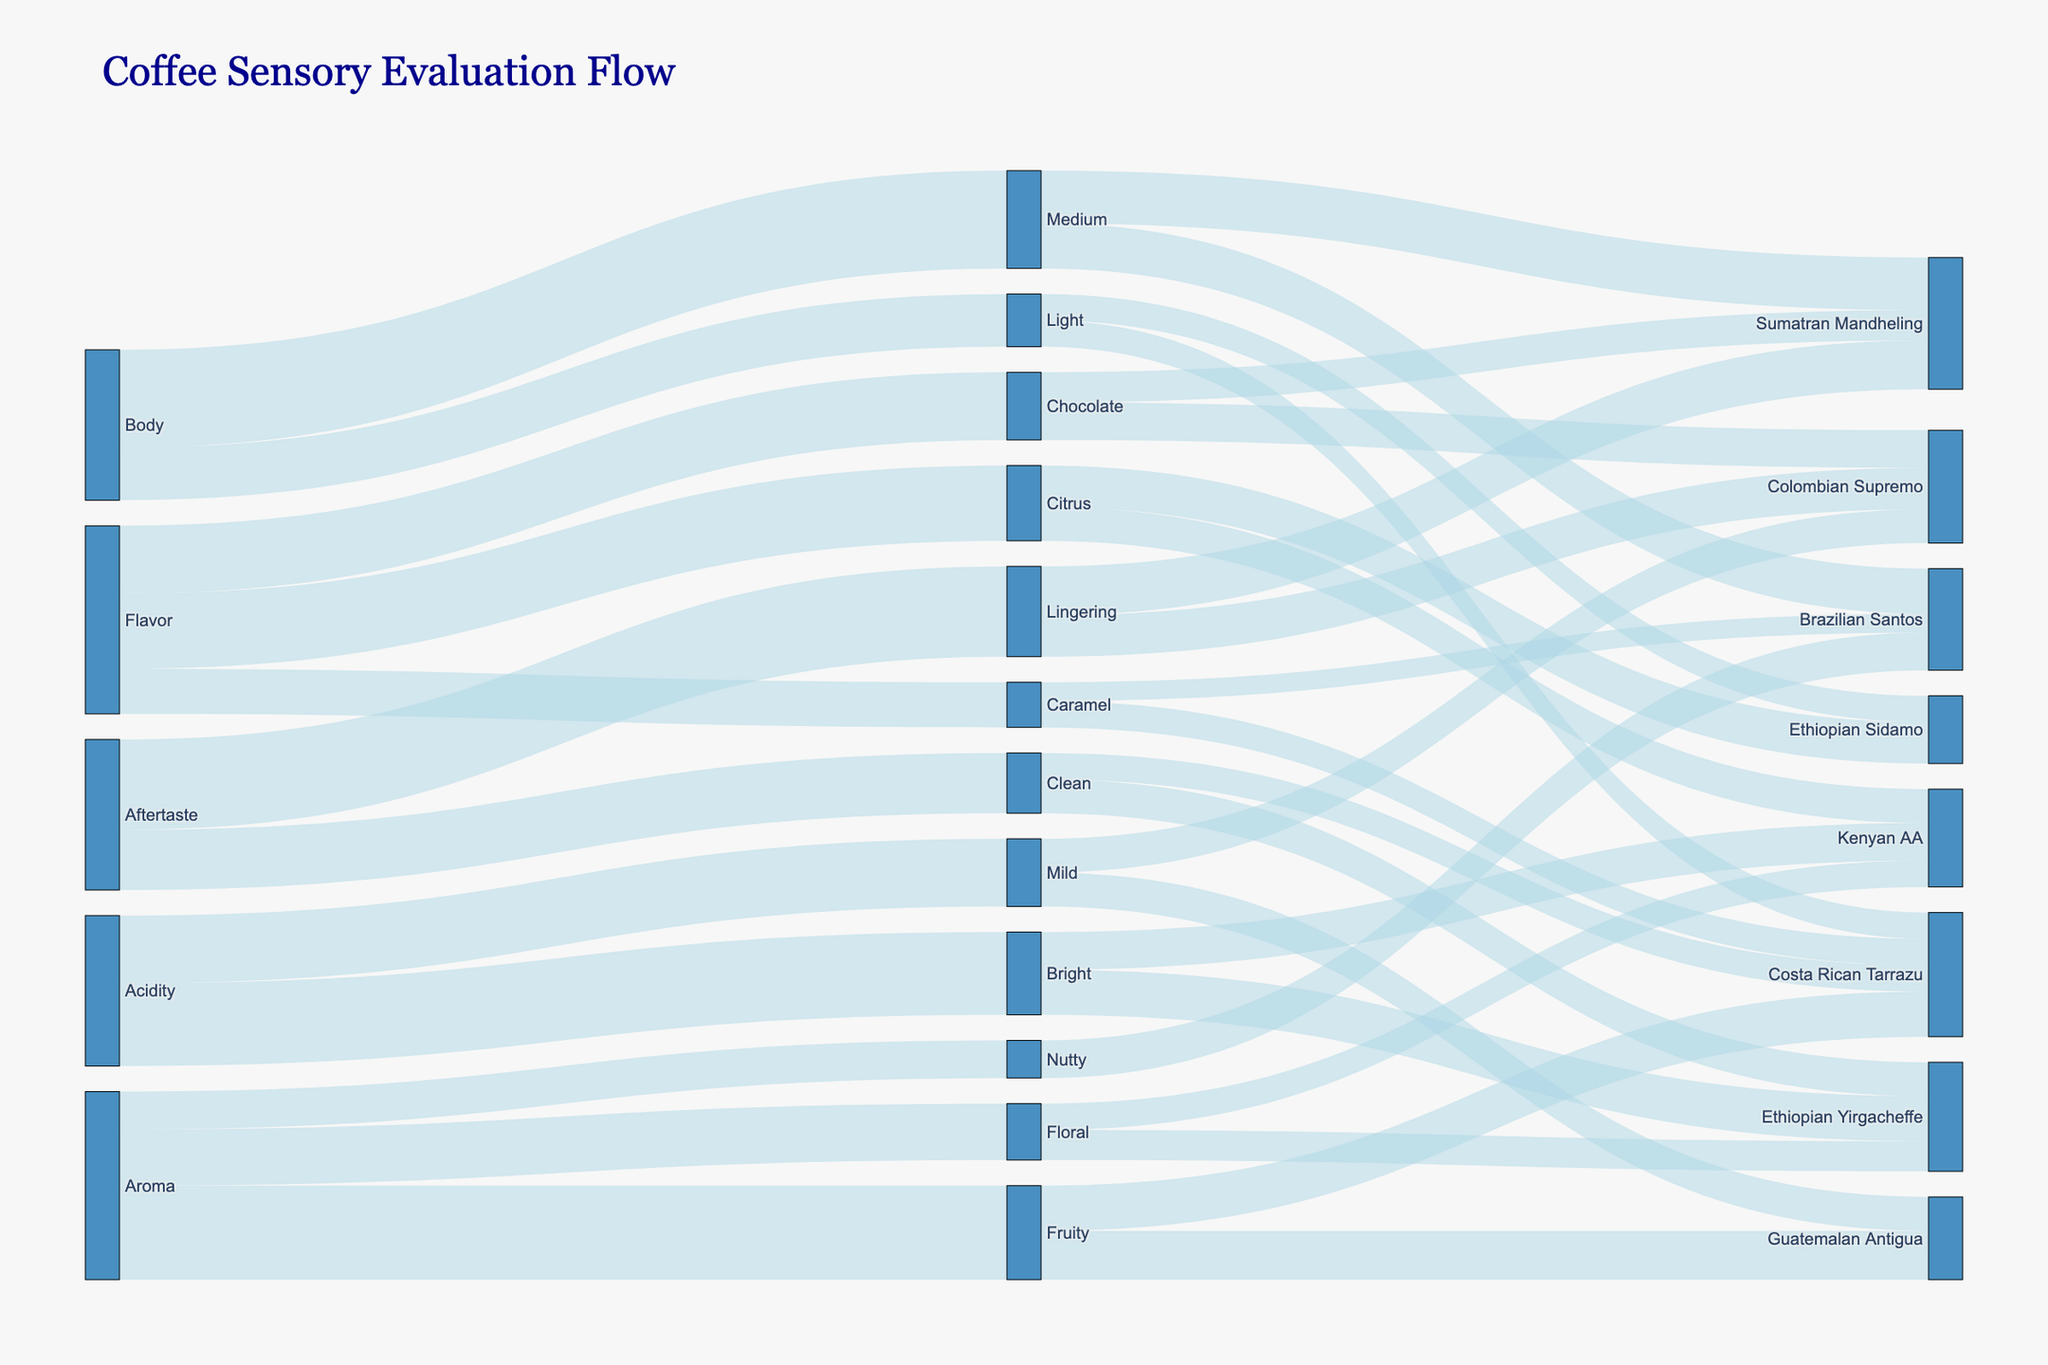What's the title of the figure? The title is usually placed at the top of the figure, making it easily identifiable. Look for a larger or bold text that summarizes the figure's content.
Answer: Coffee Sensory Evaluation Flow What are the primary attributes being evaluated in the coffee sensory sessions? The primary attributes are generally located at the left side of a Sankey Diagram, acting as the starting points for the flow.
Answer: Aroma, Flavor, Acidity, Body, Aftertaste Which coffee source has the highest value for the Fruity flavor? Identify the link labeled "Fruity" and trace the flow to the target sources. Compare the values connected to each source and find the highest one.
Answer: Guatemalan Antigua How many target categories does the attribute 'Body' have? Locate the node for 'Body' and count the number of links flowing out to its target categories.
Answer: 2 Between the coffee sources labeled as 'Bright', which one has the lowest value? Find the links associated with 'Bright' and compare the values connected to each source to identify the one with the smallest value.
Answer: Kenyan AA Which coffee source is connected to both 'Clean' and 'Lingering' aftertaste? Follow the paths from 'Clean' and 'Lingering' back to their shared target categories, then identify the common coffee source.
Answer: Sumatran Mandheling What is the total value of the 'Aroma' attribute across all its subcategories? Sum the values of all the flows originating from 'Aroma.'
Answer: 50 (15 + 25 + 10) Compare the flows from 'Chocolate' to 'Colombian Supremo' and 'Sumatran Mandheling'. Which has a higher value? Look at the links from 'Chocolate' to each of the target categories and compare their values.
Answer: Colombian Supremo Which attribute has the highest combined value flowing into the source 'Ethiopian Yirgacheffe'? Identify all the links flowing into 'Ethiopian Yirgacheffe' from various attributes and sum their values to find the highest combined value.
Answer: Aroma (Floral: 8) + Acidity (Bright: 12) + Aftertaste (Clean: 9) = 29 